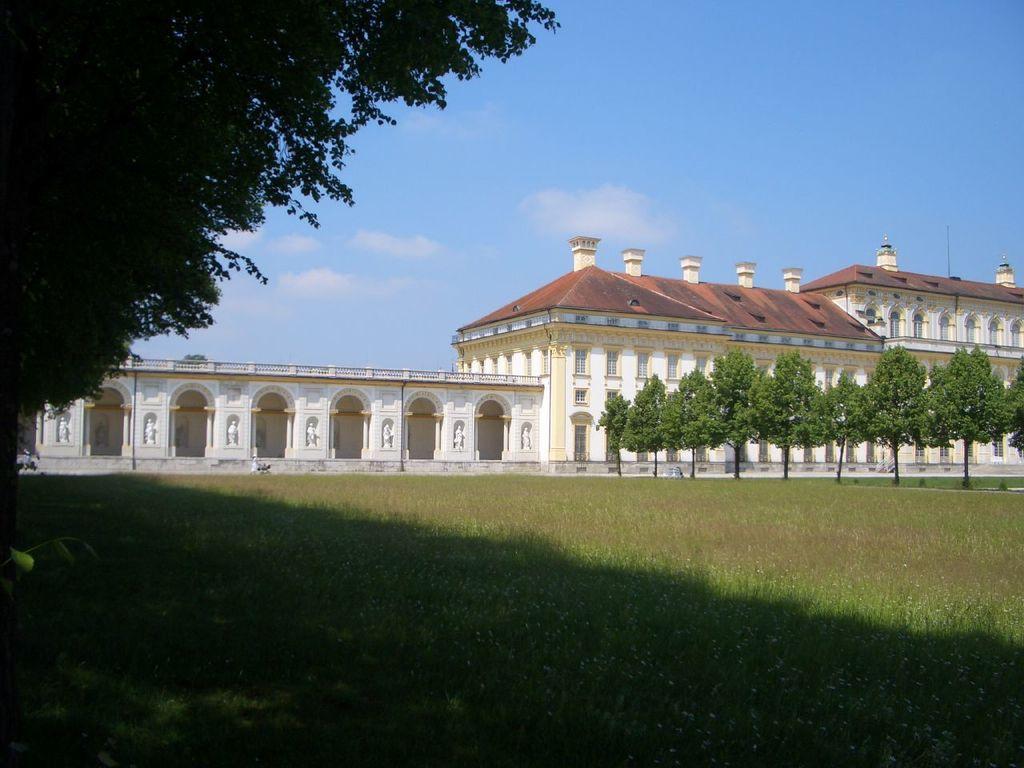Can you describe this image briefly? In this picture we can see grass, few trees and buildings, in the background we can see clouds. 